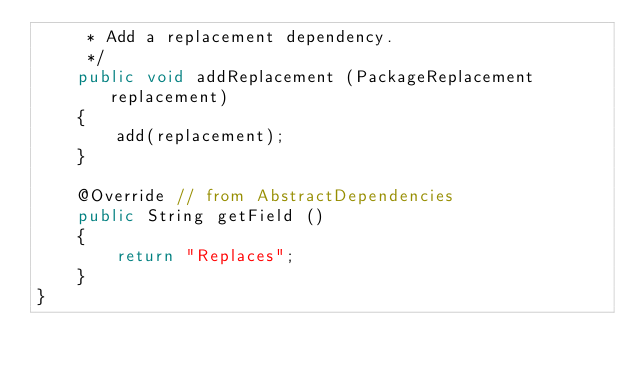Convert code to text. <code><loc_0><loc_0><loc_500><loc_500><_Java_>     * Add a replacement dependency.
     */
    public void addReplacement (PackageReplacement replacement)
    {
        add(replacement);
    }

    @Override // from AbstractDependencies
    public String getField ()
    {
        return "Replaces";
    }
}
</code> 